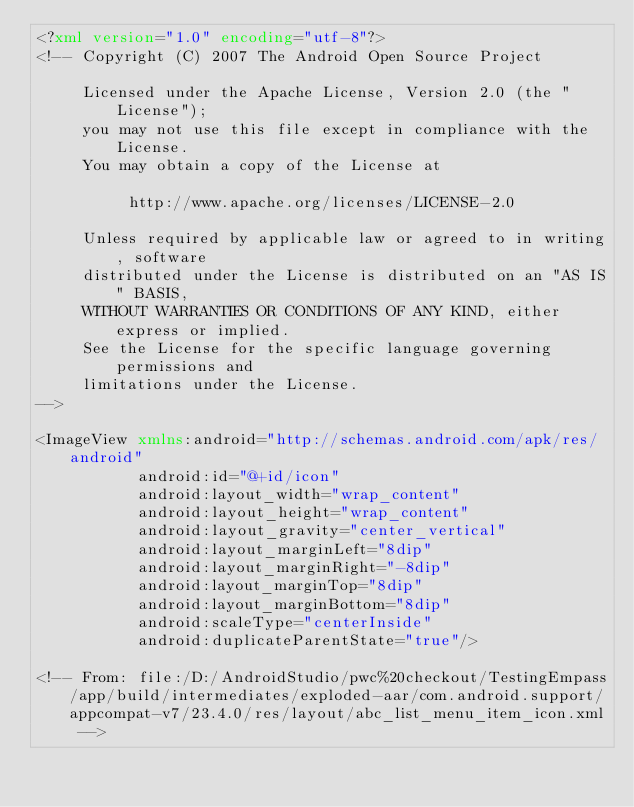<code> <loc_0><loc_0><loc_500><loc_500><_XML_><?xml version="1.0" encoding="utf-8"?>
<!-- Copyright (C) 2007 The Android Open Source Project

     Licensed under the Apache License, Version 2.0 (the "License");
     you may not use this file except in compliance with the License.
     You may obtain a copy of the License at
  
          http://www.apache.org/licenses/LICENSE-2.0
  
     Unless required by applicable law or agreed to in writing, software
     distributed under the License is distributed on an "AS IS" BASIS,
     WITHOUT WARRANTIES OR CONDITIONS OF ANY KIND, either express or implied.
     See the License for the specific language governing permissions and
     limitations under the License.
-->

<ImageView xmlns:android="http://schemas.android.com/apk/res/android"
           android:id="@+id/icon"
           android:layout_width="wrap_content"
           android:layout_height="wrap_content"
           android:layout_gravity="center_vertical"
           android:layout_marginLeft="8dip"
           android:layout_marginRight="-8dip"
           android:layout_marginTop="8dip"
           android:layout_marginBottom="8dip"
           android:scaleType="centerInside"
           android:duplicateParentState="true"/>

<!-- From: file:/D:/AndroidStudio/pwc%20checkout/TestingEmpass/app/build/intermediates/exploded-aar/com.android.support/appcompat-v7/23.4.0/res/layout/abc_list_menu_item_icon.xml --></code> 